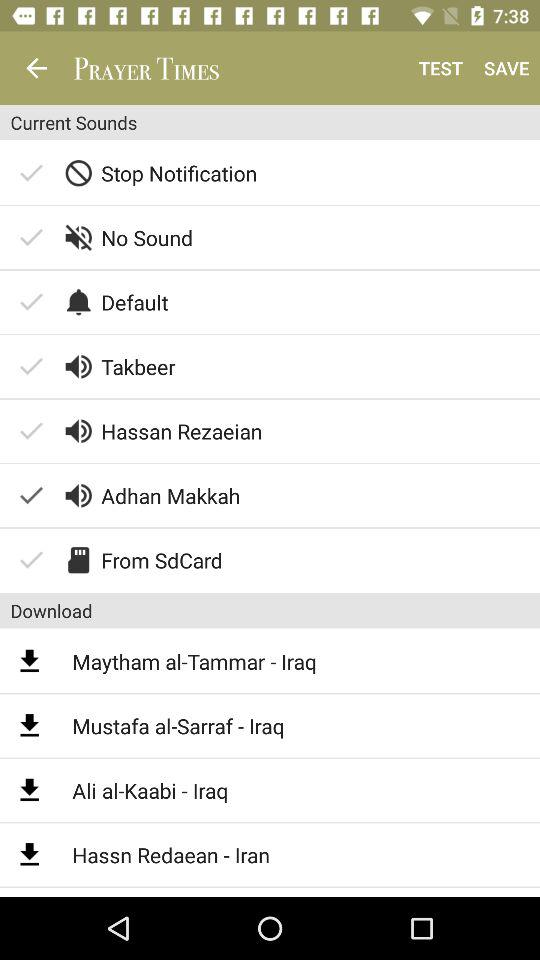Which "Current sounds" is selected? The selected "Current sounds" is "Adhan Makkah". 